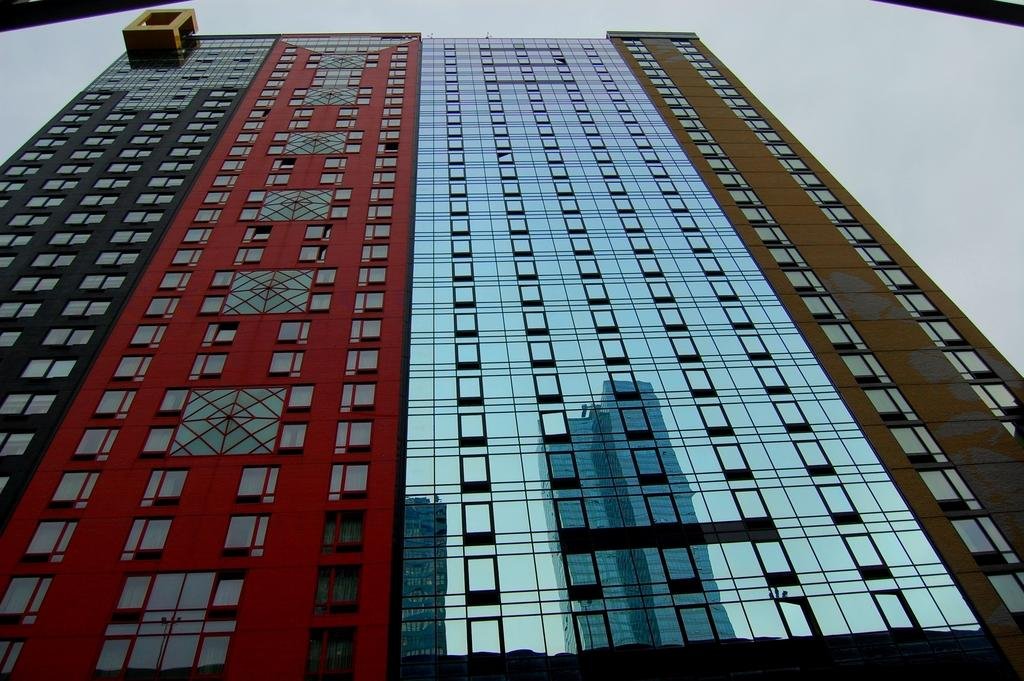What is the main structure in the image? There is a tall building in the image. What feature can be seen on the building? The building has windows (glasses). What can be seen through the windows of the building? Other buildings are visible through the windows. What is visible in the sky in the image? The sky is visible and appears cloudy. What process is being started in the image? There is no indication of a process being started in the image. What property is visible in the image? The image primarily features a tall building and its surroundings, so there is no specific property being highlighted. 